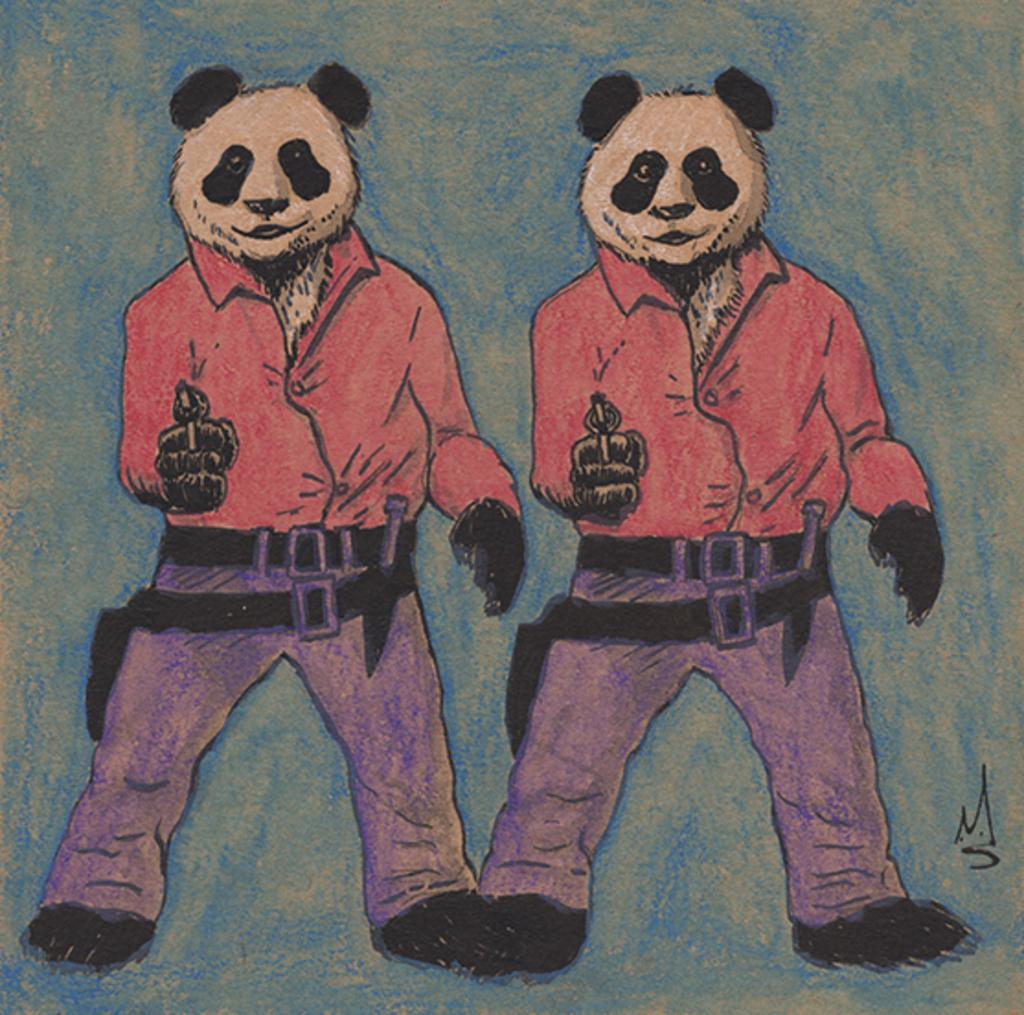What animals are depicted in the image? There is a depiction of pandas in the image. What type of family activity is taking place in the image? There is no family activity present in the image, as it only depicts pandas. How many spiders can be seen in the image? There are no spiders present in the image; it only depicts pandas. 